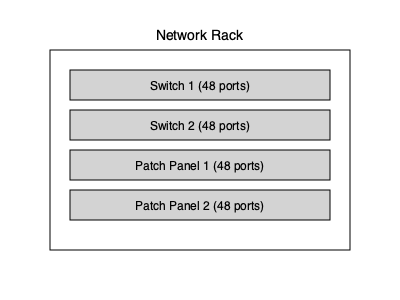Based on the network rack diagram shown, which cable management solution would be most appropriate to maintain a neat and organized infrastructure? To determine the most appropriate cable management solution, let's analyze the rack diagram step-by-step:

1. Rack content:
   - 2 switches (48 ports each)
   - 2 patch panels (48 ports each)

2. Potential cable connections:
   - Patch panel to switch connections
   - Inter-switch connections
   - Uplink connections to other network devices

3. Cable volume:
   - Potentially up to 96 cables from patch panels to switches
   - Additional cables for inter-switch and uplink connections

4. Rack space:
   - Limited space between devices
   - No visible cable management solution in place

5. Considerations for cable management:
   - Need for horizontal cable management to route cables between devices
   - Vertical cable management to guide cables along the sides of the rack
   - Must accommodate high cable density
   - Should allow for easy access and future changes

6. Appropriate solution:
   Given the high port density and limited space, a combination of horizontal and vertical cable management would be most effective:
   - Horizontal cable managers between each device for neat cable routing
   - Vertical cable managers on both sides of the rack for overall cable organization
   - Use of cable ties or velcro straps for bundling cables

This solution would help maintain a tidy infrastructure, improve airflow, facilitate easier troubleshooting, and allow for scalability.
Answer: Combination of horizontal and vertical cable managers with cable ties or velcro straps 